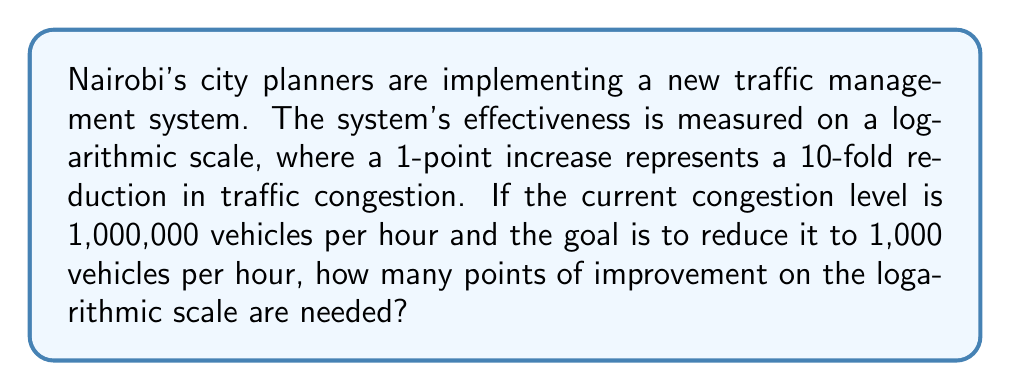What is the answer to this math problem? To solve this problem, we need to use the properties of logarithms. Let's approach this step-by-step:

1) The initial congestion level is 1,000,000 vehicles per hour.
2) The target congestion level is 1,000 vehicles per hour.
3) We need to find how many 10-fold reductions are needed to go from 1,000,000 to 1,000.

We can express this mathematically as:

$$1,000,000 \cdot 10^{-x} = 1,000$$

Where $x$ is the number of 10-fold reductions (or points on the logarithmic scale) needed.

4) Let's solve this equation:

   $$1,000,000 \cdot 10^{-x} = 1,000$$
   $$10^6 \cdot 10^{-x} = 10^3$$
   $$10^{6-x} = 10^3$$

5) For this equality to hold, the exponents must be equal:

   $$6 - x = 3$$

6) Solving for $x$:

   $$x = 6 - 3 = 3$$

Therefore, 3 points of improvement on the logarithmic scale are needed.

This can also be verified using the logarithm function:

$$\log_{10}(\frac{1,000,000}{1,000}) = \log_{10}(1000) = 3$$
Answer: 3 points 